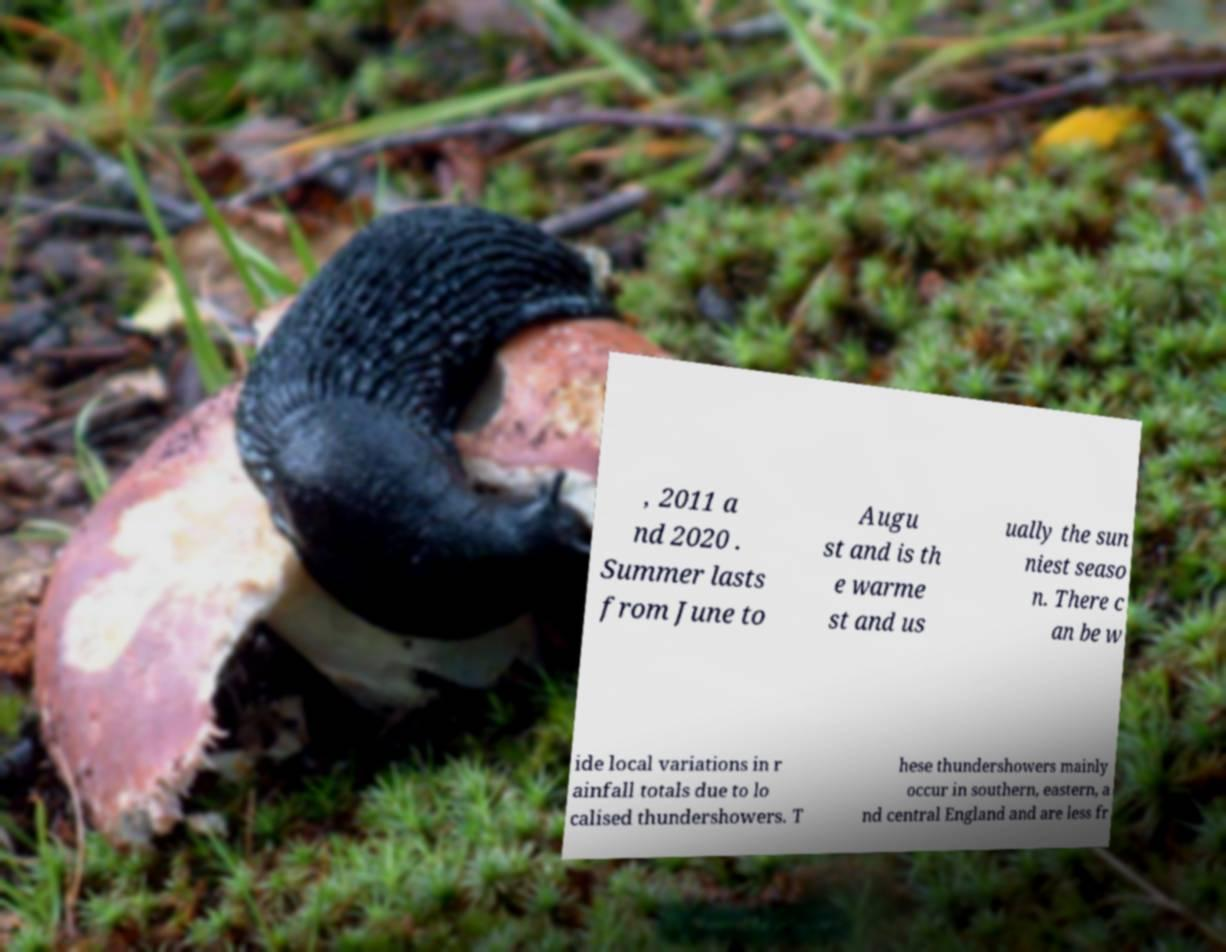Please read and relay the text visible in this image. What does it say? , 2011 a nd 2020 . Summer lasts from June to Augu st and is th e warme st and us ually the sun niest seaso n. There c an be w ide local variations in r ainfall totals due to lo calised thundershowers. T hese thundershowers mainly occur in southern, eastern, a nd central England and are less fr 